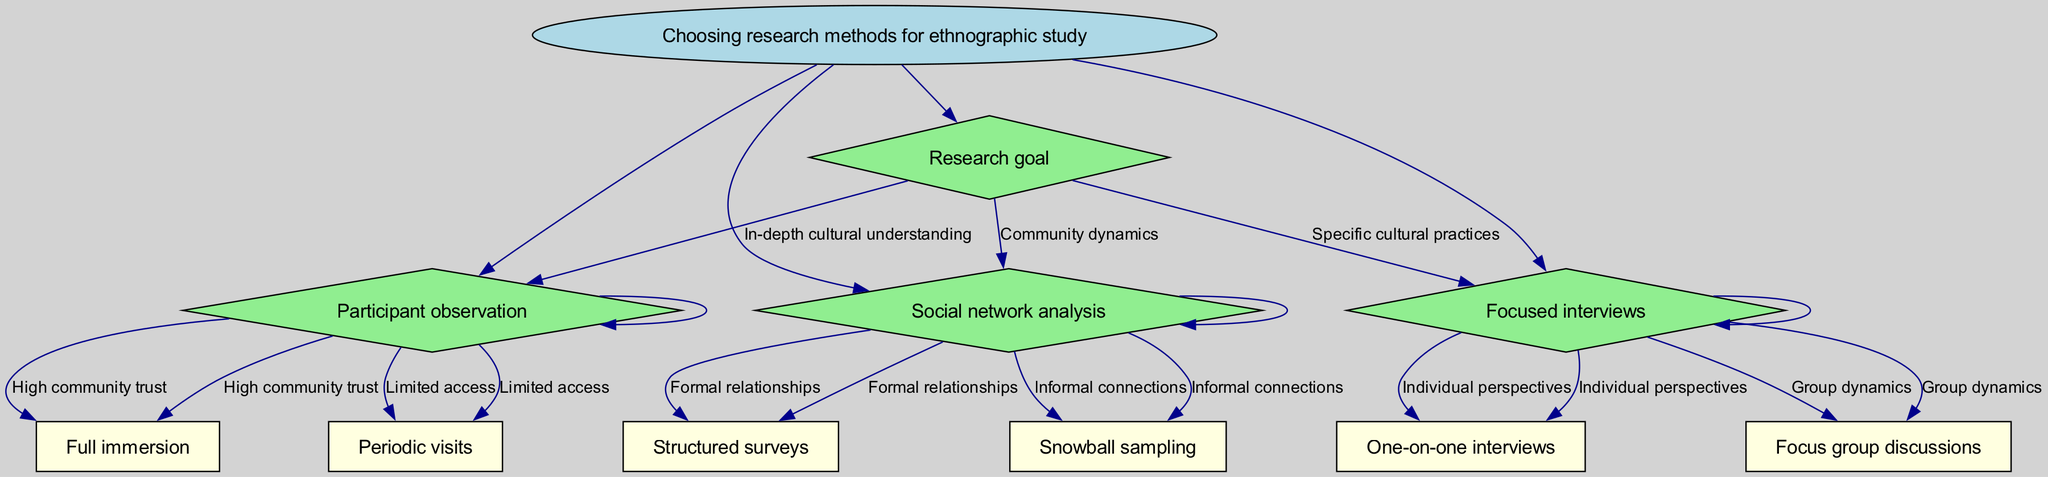What is the root node of the decision tree? The root node contains the main topic of the decision tree, which is explicitly indicated at the top of the diagram. In this case, it states "Choosing research methods for ethnographic study."
Answer: Choosing research methods for ethnographic study How many primary decisions are represented in the tree? The primary decisions are the different choices branching out from the first decision node labeled "Research goal." Each option represents a unique decision. There are three options listed here: "In-depth cultural understanding," "Specific cultural practices," and "Community dynamics."
Answer: Three What method is recommended for "In-depth cultural understanding"? The flow of the decision tree leads from the choice "In-depth cultural understanding" directly to the method recommended, which is indicated as the next step in the diagram. This leads clearly to the node labeled "Participant observation."
Answer: Participant observation If a researcher has limited access, what type of participant observation should they choose? Following the logic in the decision tree, if the initial decision leads to "Participant observation," the next decision points towards "Limited access." The recommended approach from this node is "Periodic visits."
Answer: Periodic visits What follows after "Structured surveys" in the decision tree? The node "Structured surveys" leads to no further options in the displayed diagram. It is located at the end of this branch, so there are no subsequent decisions or options following it.
Answer: None Which method is concerned with "Group dynamics"? The decision tree indicates that the method suitable for exploring "Group dynamics" follows from the choice related to "Focused interviews." This leads to "Focus group discussions" as the appropriate method for this aspect.
Answer: Focus group discussions What is the total number of methods listed in the diagram? By reviewing the end nodes of the decision tree, you can count that there are a total of six distinct methods available: "Full immersion," "Periodic visits," "One-on-one interviews," "Focus group discussions," "Structured surveys," and "Snowball sampling."
Answer: Six What is the second decision option listed under "Social network analysis"? The flow to the second decision option is determined by reviewing the choices provided after reaching the node labeled "Social network analysis." It specifically lists "Informal connections" leading to "Snowball sampling."
Answer: Snowball sampling 